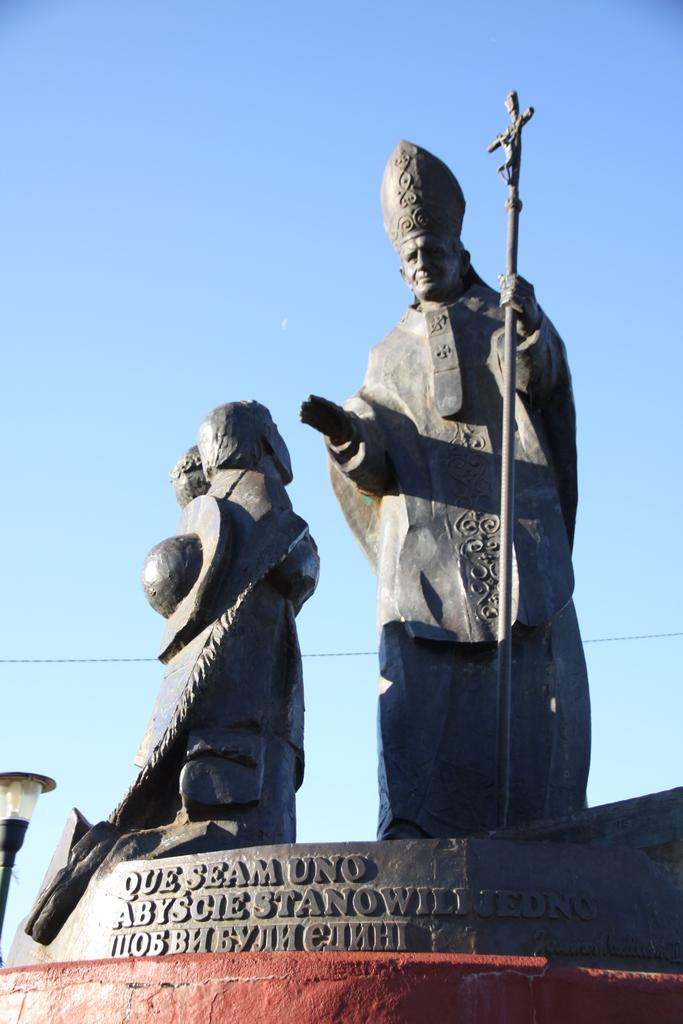What type of art is present in the image? There are sculptures in the image. Are there any words or letters in the image? Yes, there is text in the image. Where is the light source located in the image? The light is in the bottom left of the image. What can be seen in the distance in the image? The sky is visible in the background of the image. What type of zinc is used to create the sculptures in the image? There is no information about the materials used to create the sculptures in the image, so it cannot be determined if zinc was used. 